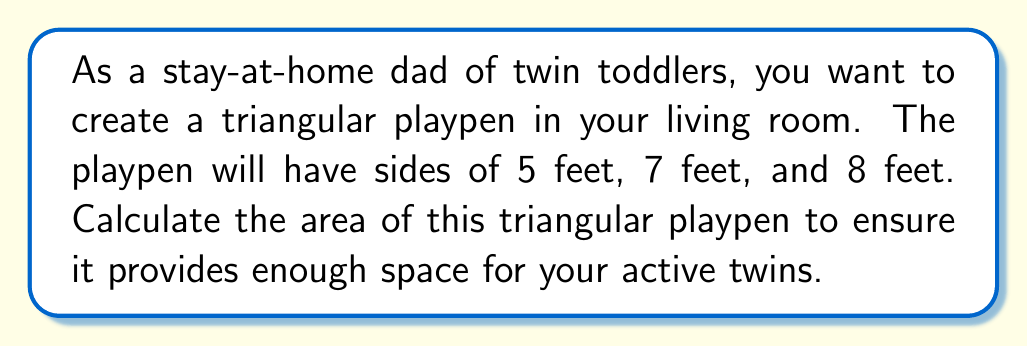Give your solution to this math problem. To find the area of a triangle when we know the lengths of all three sides, we can use Heron's formula. Let's follow these steps:

1) First, recall Heron's formula:
   $$A = \sqrt{s(s-a)(s-b)(s-c)}$$
   where $A$ is the area, $a$, $b$, and $c$ are the side lengths, and $s$ is the semi-perimeter.

2) Calculate the semi-perimeter $s$:
   $$s = \frac{a + b + c}{2} = \frac{5 + 7 + 8}{2} = \frac{20}{2} = 10$$

3) Now, let's substitute these values into Heron's formula:
   $$A = \sqrt{10(10-5)(10-7)(10-8)}$$
   $$A = \sqrt{10 \cdot 5 \cdot 3 \cdot 2}$$
   $$A = \sqrt{300}$$

4) Simplify the square root:
   $$A = 10\sqrt{3}$$

5) To get a decimal approximation:
   $$A \approx 17.32 \text{ square feet}$$

[asy]
unitsize(20);
draw((0,0)--(5,0)--(2.5,3.5)--cycle);
label("5'",(2.5,0),S);
label("7'",(3.75,1.75),NE);
label("8'",(1.25,1.75),NW);
[/asy]

This area should provide enough space for your twin toddlers to play safely within the triangular playpen.
Answer: The area of the triangular playpen is $10\sqrt{3}$ square feet, or approximately 17.32 square feet. 